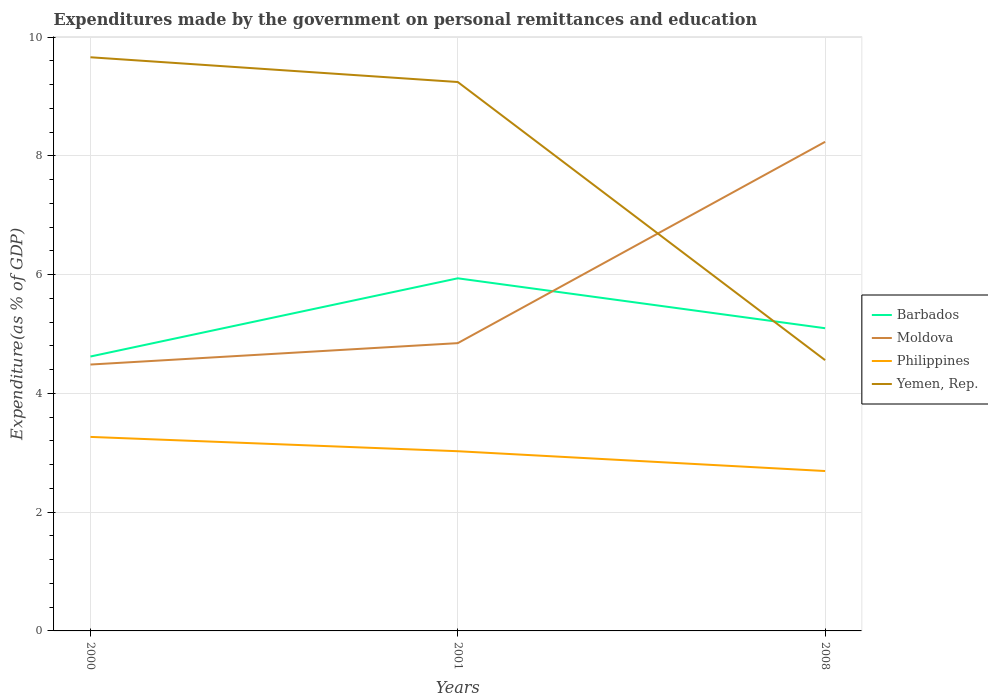How many different coloured lines are there?
Your answer should be very brief. 4. Does the line corresponding to Moldova intersect with the line corresponding to Yemen, Rep.?
Your response must be concise. Yes. Is the number of lines equal to the number of legend labels?
Offer a terse response. Yes. Across all years, what is the maximum expenditures made by the government on personal remittances and education in Philippines?
Ensure brevity in your answer.  2.69. In which year was the expenditures made by the government on personal remittances and education in Philippines maximum?
Make the answer very short. 2008. What is the total expenditures made by the government on personal remittances and education in Yemen, Rep. in the graph?
Keep it short and to the point. 0.42. What is the difference between the highest and the second highest expenditures made by the government on personal remittances and education in Moldova?
Provide a succinct answer. 3.75. What is the difference between the highest and the lowest expenditures made by the government on personal remittances and education in Moldova?
Provide a succinct answer. 1. Is the expenditures made by the government on personal remittances and education in Barbados strictly greater than the expenditures made by the government on personal remittances and education in Moldova over the years?
Give a very brief answer. No. How many lines are there?
Provide a succinct answer. 4. How many years are there in the graph?
Your response must be concise. 3. Are the values on the major ticks of Y-axis written in scientific E-notation?
Your response must be concise. No. Does the graph contain any zero values?
Your answer should be compact. No. How many legend labels are there?
Ensure brevity in your answer.  4. What is the title of the graph?
Make the answer very short. Expenditures made by the government on personal remittances and education. What is the label or title of the X-axis?
Offer a terse response. Years. What is the label or title of the Y-axis?
Provide a succinct answer. Expenditure(as % of GDP). What is the Expenditure(as % of GDP) in Barbados in 2000?
Give a very brief answer. 4.62. What is the Expenditure(as % of GDP) of Moldova in 2000?
Your answer should be compact. 4.49. What is the Expenditure(as % of GDP) of Philippines in 2000?
Provide a succinct answer. 3.27. What is the Expenditure(as % of GDP) of Yemen, Rep. in 2000?
Offer a terse response. 9.66. What is the Expenditure(as % of GDP) in Barbados in 2001?
Offer a very short reply. 5.94. What is the Expenditure(as % of GDP) of Moldova in 2001?
Provide a succinct answer. 4.85. What is the Expenditure(as % of GDP) in Philippines in 2001?
Provide a succinct answer. 3.03. What is the Expenditure(as % of GDP) of Yemen, Rep. in 2001?
Give a very brief answer. 9.24. What is the Expenditure(as % of GDP) of Barbados in 2008?
Keep it short and to the point. 5.1. What is the Expenditure(as % of GDP) in Moldova in 2008?
Offer a very short reply. 8.24. What is the Expenditure(as % of GDP) in Philippines in 2008?
Provide a short and direct response. 2.69. What is the Expenditure(as % of GDP) of Yemen, Rep. in 2008?
Provide a short and direct response. 4.56. Across all years, what is the maximum Expenditure(as % of GDP) in Barbados?
Ensure brevity in your answer.  5.94. Across all years, what is the maximum Expenditure(as % of GDP) in Moldova?
Provide a succinct answer. 8.24. Across all years, what is the maximum Expenditure(as % of GDP) in Philippines?
Ensure brevity in your answer.  3.27. Across all years, what is the maximum Expenditure(as % of GDP) in Yemen, Rep.?
Provide a short and direct response. 9.66. Across all years, what is the minimum Expenditure(as % of GDP) in Barbados?
Give a very brief answer. 4.62. Across all years, what is the minimum Expenditure(as % of GDP) in Moldova?
Ensure brevity in your answer.  4.49. Across all years, what is the minimum Expenditure(as % of GDP) in Philippines?
Your response must be concise. 2.69. Across all years, what is the minimum Expenditure(as % of GDP) in Yemen, Rep.?
Provide a short and direct response. 4.56. What is the total Expenditure(as % of GDP) of Barbados in the graph?
Keep it short and to the point. 15.66. What is the total Expenditure(as % of GDP) of Moldova in the graph?
Your answer should be very brief. 17.57. What is the total Expenditure(as % of GDP) of Philippines in the graph?
Your answer should be very brief. 8.99. What is the total Expenditure(as % of GDP) of Yemen, Rep. in the graph?
Make the answer very short. 23.47. What is the difference between the Expenditure(as % of GDP) of Barbados in 2000 and that in 2001?
Your response must be concise. -1.32. What is the difference between the Expenditure(as % of GDP) of Moldova in 2000 and that in 2001?
Your response must be concise. -0.36. What is the difference between the Expenditure(as % of GDP) of Philippines in 2000 and that in 2001?
Provide a short and direct response. 0.24. What is the difference between the Expenditure(as % of GDP) in Yemen, Rep. in 2000 and that in 2001?
Offer a very short reply. 0.42. What is the difference between the Expenditure(as % of GDP) of Barbados in 2000 and that in 2008?
Ensure brevity in your answer.  -0.48. What is the difference between the Expenditure(as % of GDP) of Moldova in 2000 and that in 2008?
Provide a succinct answer. -3.75. What is the difference between the Expenditure(as % of GDP) in Philippines in 2000 and that in 2008?
Make the answer very short. 0.57. What is the difference between the Expenditure(as % of GDP) in Yemen, Rep. in 2000 and that in 2008?
Give a very brief answer. 5.1. What is the difference between the Expenditure(as % of GDP) in Barbados in 2001 and that in 2008?
Give a very brief answer. 0.84. What is the difference between the Expenditure(as % of GDP) in Moldova in 2001 and that in 2008?
Ensure brevity in your answer.  -3.39. What is the difference between the Expenditure(as % of GDP) in Philippines in 2001 and that in 2008?
Your response must be concise. 0.33. What is the difference between the Expenditure(as % of GDP) in Yemen, Rep. in 2001 and that in 2008?
Offer a terse response. 4.68. What is the difference between the Expenditure(as % of GDP) in Barbados in 2000 and the Expenditure(as % of GDP) in Moldova in 2001?
Your answer should be very brief. -0.23. What is the difference between the Expenditure(as % of GDP) of Barbados in 2000 and the Expenditure(as % of GDP) of Philippines in 2001?
Keep it short and to the point. 1.59. What is the difference between the Expenditure(as % of GDP) of Barbados in 2000 and the Expenditure(as % of GDP) of Yemen, Rep. in 2001?
Give a very brief answer. -4.62. What is the difference between the Expenditure(as % of GDP) of Moldova in 2000 and the Expenditure(as % of GDP) of Philippines in 2001?
Ensure brevity in your answer.  1.46. What is the difference between the Expenditure(as % of GDP) in Moldova in 2000 and the Expenditure(as % of GDP) in Yemen, Rep. in 2001?
Provide a succinct answer. -4.76. What is the difference between the Expenditure(as % of GDP) in Philippines in 2000 and the Expenditure(as % of GDP) in Yemen, Rep. in 2001?
Your answer should be very brief. -5.98. What is the difference between the Expenditure(as % of GDP) of Barbados in 2000 and the Expenditure(as % of GDP) of Moldova in 2008?
Offer a terse response. -3.62. What is the difference between the Expenditure(as % of GDP) in Barbados in 2000 and the Expenditure(as % of GDP) in Philippines in 2008?
Provide a short and direct response. 1.93. What is the difference between the Expenditure(as % of GDP) of Barbados in 2000 and the Expenditure(as % of GDP) of Yemen, Rep. in 2008?
Provide a short and direct response. 0.06. What is the difference between the Expenditure(as % of GDP) in Moldova in 2000 and the Expenditure(as % of GDP) in Philippines in 2008?
Ensure brevity in your answer.  1.79. What is the difference between the Expenditure(as % of GDP) in Moldova in 2000 and the Expenditure(as % of GDP) in Yemen, Rep. in 2008?
Give a very brief answer. -0.07. What is the difference between the Expenditure(as % of GDP) in Philippines in 2000 and the Expenditure(as % of GDP) in Yemen, Rep. in 2008?
Your answer should be very brief. -1.29. What is the difference between the Expenditure(as % of GDP) of Barbados in 2001 and the Expenditure(as % of GDP) of Moldova in 2008?
Your answer should be very brief. -2.3. What is the difference between the Expenditure(as % of GDP) of Barbados in 2001 and the Expenditure(as % of GDP) of Philippines in 2008?
Give a very brief answer. 3.25. What is the difference between the Expenditure(as % of GDP) in Barbados in 2001 and the Expenditure(as % of GDP) in Yemen, Rep. in 2008?
Make the answer very short. 1.38. What is the difference between the Expenditure(as % of GDP) in Moldova in 2001 and the Expenditure(as % of GDP) in Philippines in 2008?
Your answer should be very brief. 2.15. What is the difference between the Expenditure(as % of GDP) of Moldova in 2001 and the Expenditure(as % of GDP) of Yemen, Rep. in 2008?
Make the answer very short. 0.29. What is the difference between the Expenditure(as % of GDP) of Philippines in 2001 and the Expenditure(as % of GDP) of Yemen, Rep. in 2008?
Provide a short and direct response. -1.53. What is the average Expenditure(as % of GDP) in Barbados per year?
Offer a very short reply. 5.22. What is the average Expenditure(as % of GDP) of Moldova per year?
Keep it short and to the point. 5.86. What is the average Expenditure(as % of GDP) of Philippines per year?
Offer a very short reply. 3. What is the average Expenditure(as % of GDP) in Yemen, Rep. per year?
Ensure brevity in your answer.  7.82. In the year 2000, what is the difference between the Expenditure(as % of GDP) in Barbados and Expenditure(as % of GDP) in Moldova?
Your answer should be very brief. 0.14. In the year 2000, what is the difference between the Expenditure(as % of GDP) of Barbados and Expenditure(as % of GDP) of Philippines?
Your response must be concise. 1.35. In the year 2000, what is the difference between the Expenditure(as % of GDP) of Barbados and Expenditure(as % of GDP) of Yemen, Rep.?
Provide a short and direct response. -5.04. In the year 2000, what is the difference between the Expenditure(as % of GDP) of Moldova and Expenditure(as % of GDP) of Philippines?
Offer a terse response. 1.22. In the year 2000, what is the difference between the Expenditure(as % of GDP) of Moldova and Expenditure(as % of GDP) of Yemen, Rep.?
Your response must be concise. -5.18. In the year 2000, what is the difference between the Expenditure(as % of GDP) of Philippines and Expenditure(as % of GDP) of Yemen, Rep.?
Make the answer very short. -6.39. In the year 2001, what is the difference between the Expenditure(as % of GDP) of Barbados and Expenditure(as % of GDP) of Moldova?
Provide a succinct answer. 1.09. In the year 2001, what is the difference between the Expenditure(as % of GDP) in Barbados and Expenditure(as % of GDP) in Philippines?
Provide a short and direct response. 2.91. In the year 2001, what is the difference between the Expenditure(as % of GDP) of Barbados and Expenditure(as % of GDP) of Yemen, Rep.?
Your answer should be compact. -3.31. In the year 2001, what is the difference between the Expenditure(as % of GDP) of Moldova and Expenditure(as % of GDP) of Philippines?
Give a very brief answer. 1.82. In the year 2001, what is the difference between the Expenditure(as % of GDP) in Moldova and Expenditure(as % of GDP) in Yemen, Rep.?
Provide a short and direct response. -4.4. In the year 2001, what is the difference between the Expenditure(as % of GDP) of Philippines and Expenditure(as % of GDP) of Yemen, Rep.?
Make the answer very short. -6.22. In the year 2008, what is the difference between the Expenditure(as % of GDP) in Barbados and Expenditure(as % of GDP) in Moldova?
Make the answer very short. -3.14. In the year 2008, what is the difference between the Expenditure(as % of GDP) in Barbados and Expenditure(as % of GDP) in Philippines?
Offer a terse response. 2.4. In the year 2008, what is the difference between the Expenditure(as % of GDP) in Barbados and Expenditure(as % of GDP) in Yemen, Rep.?
Make the answer very short. 0.54. In the year 2008, what is the difference between the Expenditure(as % of GDP) of Moldova and Expenditure(as % of GDP) of Philippines?
Ensure brevity in your answer.  5.54. In the year 2008, what is the difference between the Expenditure(as % of GDP) of Moldova and Expenditure(as % of GDP) of Yemen, Rep.?
Offer a very short reply. 3.68. In the year 2008, what is the difference between the Expenditure(as % of GDP) of Philippines and Expenditure(as % of GDP) of Yemen, Rep.?
Provide a short and direct response. -1.87. What is the ratio of the Expenditure(as % of GDP) of Barbados in 2000 to that in 2001?
Your response must be concise. 0.78. What is the ratio of the Expenditure(as % of GDP) of Moldova in 2000 to that in 2001?
Ensure brevity in your answer.  0.93. What is the ratio of the Expenditure(as % of GDP) of Philippines in 2000 to that in 2001?
Keep it short and to the point. 1.08. What is the ratio of the Expenditure(as % of GDP) of Yemen, Rep. in 2000 to that in 2001?
Make the answer very short. 1.05. What is the ratio of the Expenditure(as % of GDP) of Barbados in 2000 to that in 2008?
Give a very brief answer. 0.91. What is the ratio of the Expenditure(as % of GDP) of Moldova in 2000 to that in 2008?
Keep it short and to the point. 0.54. What is the ratio of the Expenditure(as % of GDP) of Philippines in 2000 to that in 2008?
Keep it short and to the point. 1.21. What is the ratio of the Expenditure(as % of GDP) in Yemen, Rep. in 2000 to that in 2008?
Provide a succinct answer. 2.12. What is the ratio of the Expenditure(as % of GDP) in Barbados in 2001 to that in 2008?
Provide a succinct answer. 1.17. What is the ratio of the Expenditure(as % of GDP) of Moldova in 2001 to that in 2008?
Your response must be concise. 0.59. What is the ratio of the Expenditure(as % of GDP) in Philippines in 2001 to that in 2008?
Keep it short and to the point. 1.12. What is the ratio of the Expenditure(as % of GDP) in Yemen, Rep. in 2001 to that in 2008?
Ensure brevity in your answer.  2.03. What is the difference between the highest and the second highest Expenditure(as % of GDP) in Barbados?
Your answer should be compact. 0.84. What is the difference between the highest and the second highest Expenditure(as % of GDP) of Moldova?
Your answer should be compact. 3.39. What is the difference between the highest and the second highest Expenditure(as % of GDP) in Philippines?
Your response must be concise. 0.24. What is the difference between the highest and the second highest Expenditure(as % of GDP) in Yemen, Rep.?
Offer a terse response. 0.42. What is the difference between the highest and the lowest Expenditure(as % of GDP) in Barbados?
Keep it short and to the point. 1.32. What is the difference between the highest and the lowest Expenditure(as % of GDP) in Moldova?
Offer a terse response. 3.75. What is the difference between the highest and the lowest Expenditure(as % of GDP) in Philippines?
Provide a short and direct response. 0.57. What is the difference between the highest and the lowest Expenditure(as % of GDP) in Yemen, Rep.?
Provide a succinct answer. 5.1. 